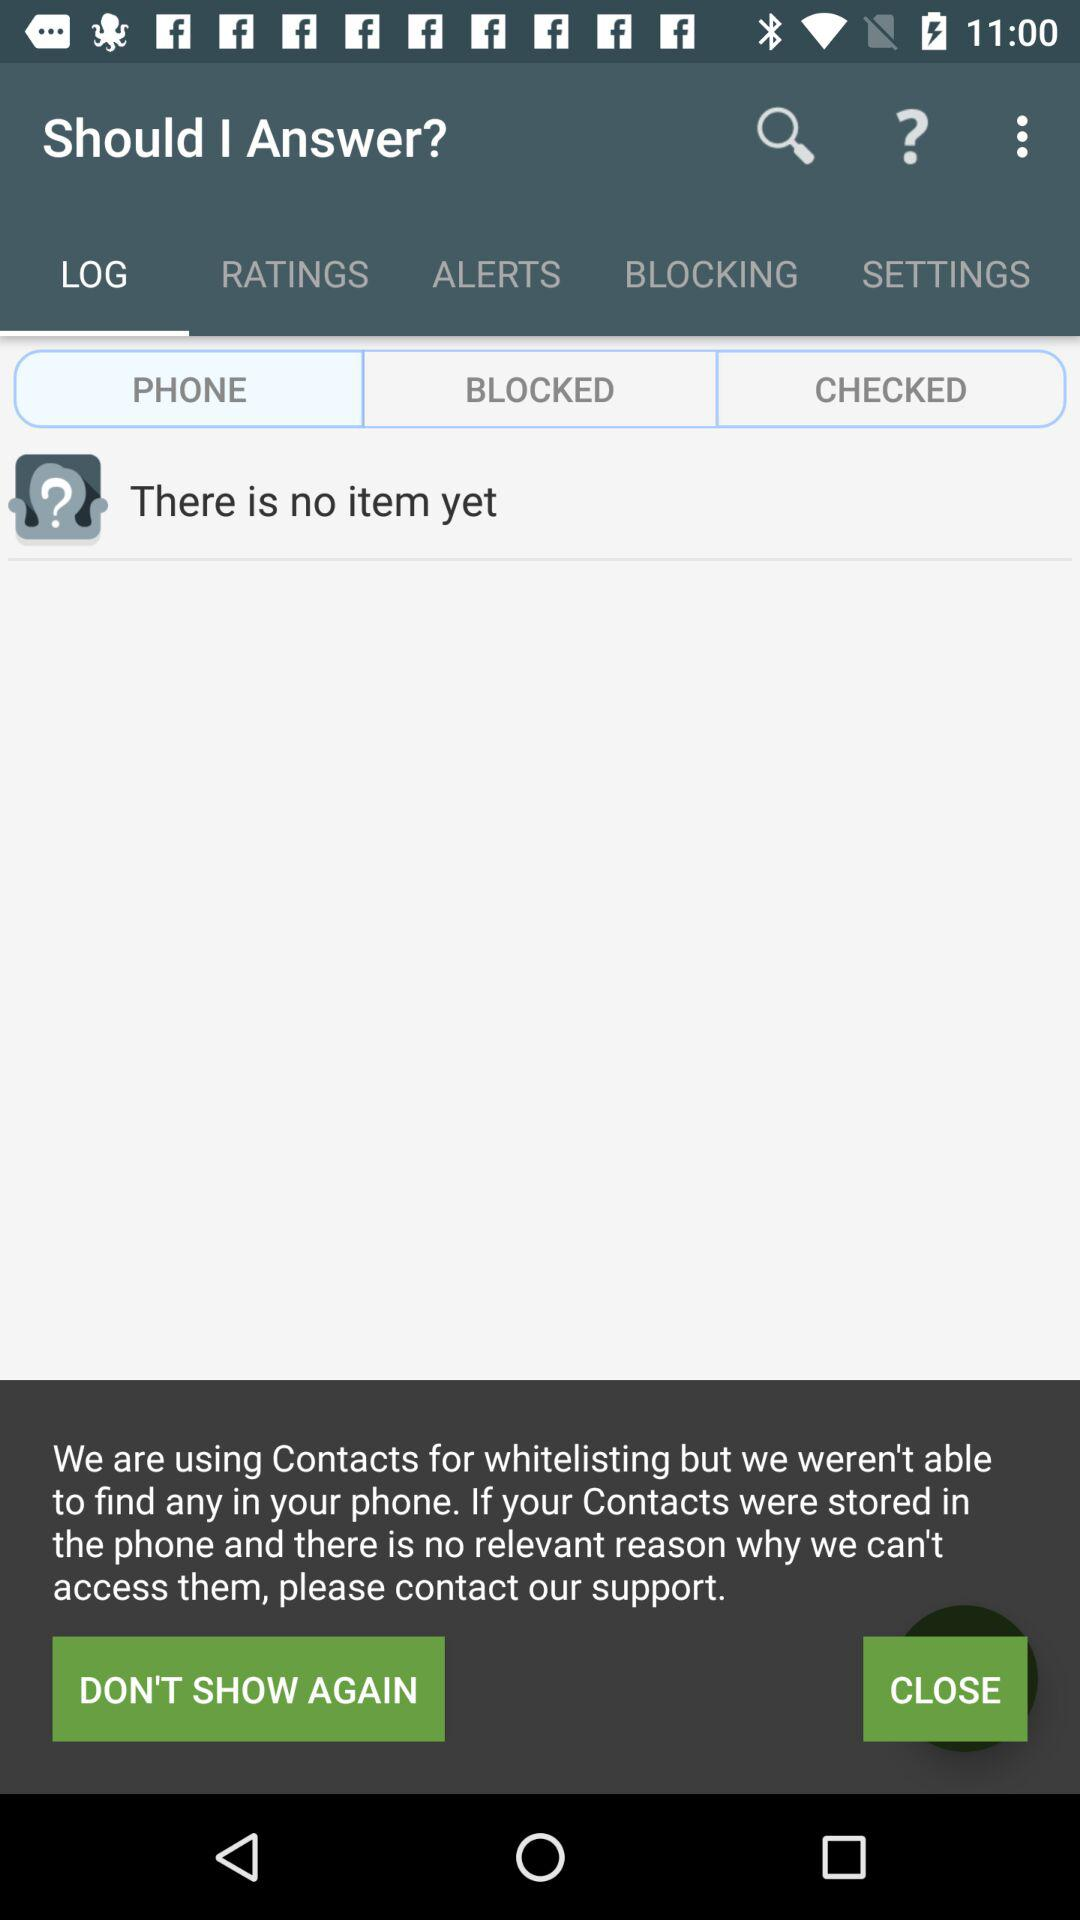Which tab am I using? You are using the "LOG" and "PHONE" tabs. 